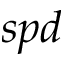Convert formula to latex. <formula><loc_0><loc_0><loc_500><loc_500>s p d</formula> 